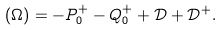Convert formula to latex. <formula><loc_0><loc_0><loc_500><loc_500>( \Omega ) = - P ^ { + } _ { 0 } - Q ^ { + } _ { 0 } + \mathcal { D } + \mathcal { D } ^ { + } .</formula> 